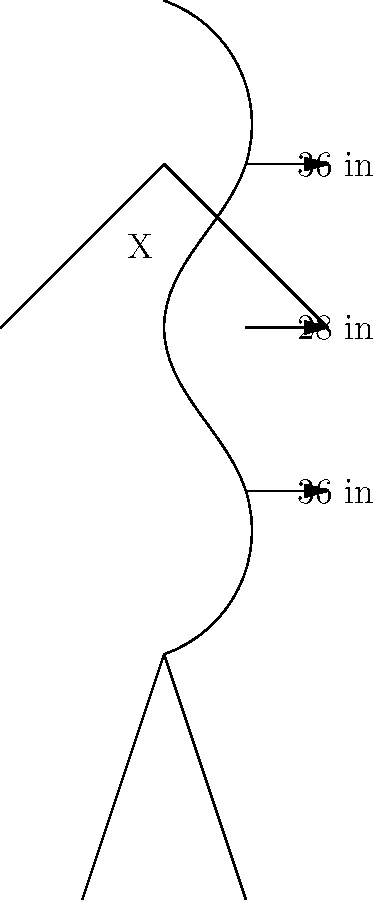In the fashion industry, the "golden ratio" for body measurements is often cited as 36-24-36 inches (bust-waist-hip). Given the measurements shown in the diagram, what should the waist measurement (X) be in inches to achieve this ideal ratio? To determine the ideal waist measurement for the "golden ratio," we need to follow these steps:

1. Identify the given measurements:
   - Bust: 36 inches
   - Hips: 36 inches
   - Current waist: 28 inches

2. Recall the ideal "golden ratio":
   - Bust: 36 inches
   - Waist: 24 inches
   - Hips: 36 inches

3. Compare the given measurements to the ideal ratio:
   - The bust and hip measurements already match the ideal ratio (36 inches).
   - The waist measurement needs to be adjusted.

4. Calculate the difference between the current waist and the ideal waist:
   $28 \text{ inches} - 24 \text{ inches} = 4 \text{ inches}$

5. Determine the required change:
   The waist needs to be reduced by 4 inches to achieve the ideal ratio.

Therefore, the waist measurement (X) should be 24 inches to achieve the "golden ratio" of 36-24-36.
Answer: 24 inches 